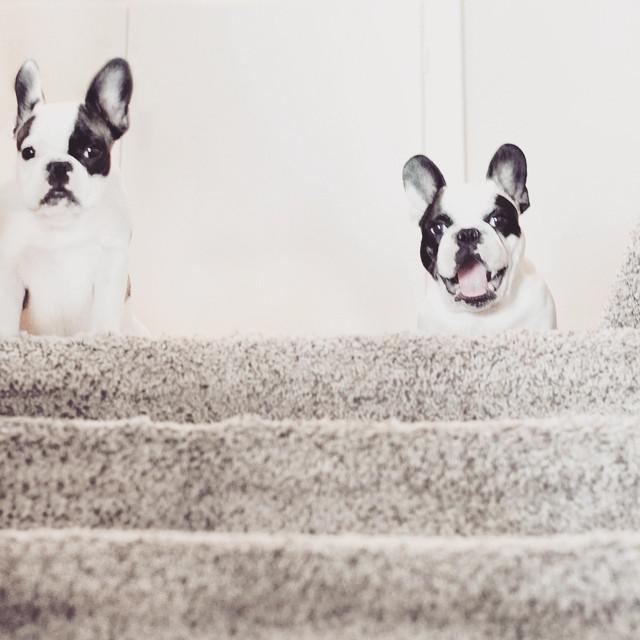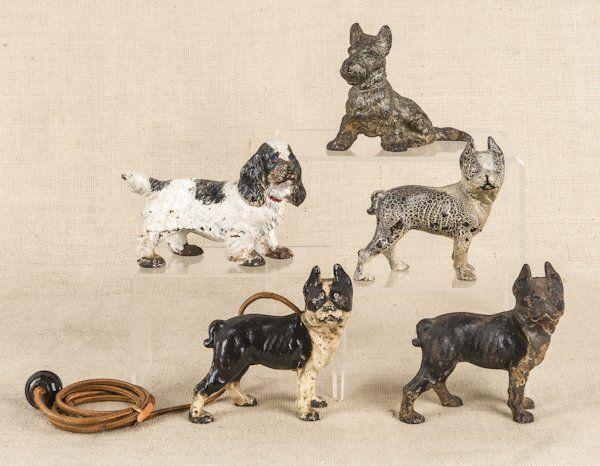The first image is the image on the left, the second image is the image on the right. Assess this claim about the two images: "A total of seven dog figures are shown.". Correct or not? Answer yes or no. Yes. The first image is the image on the left, the second image is the image on the right. Examine the images to the left and right. Is the description "There are at least two living breathing Bulldogs looking forward." accurate? Answer yes or no. Yes. 